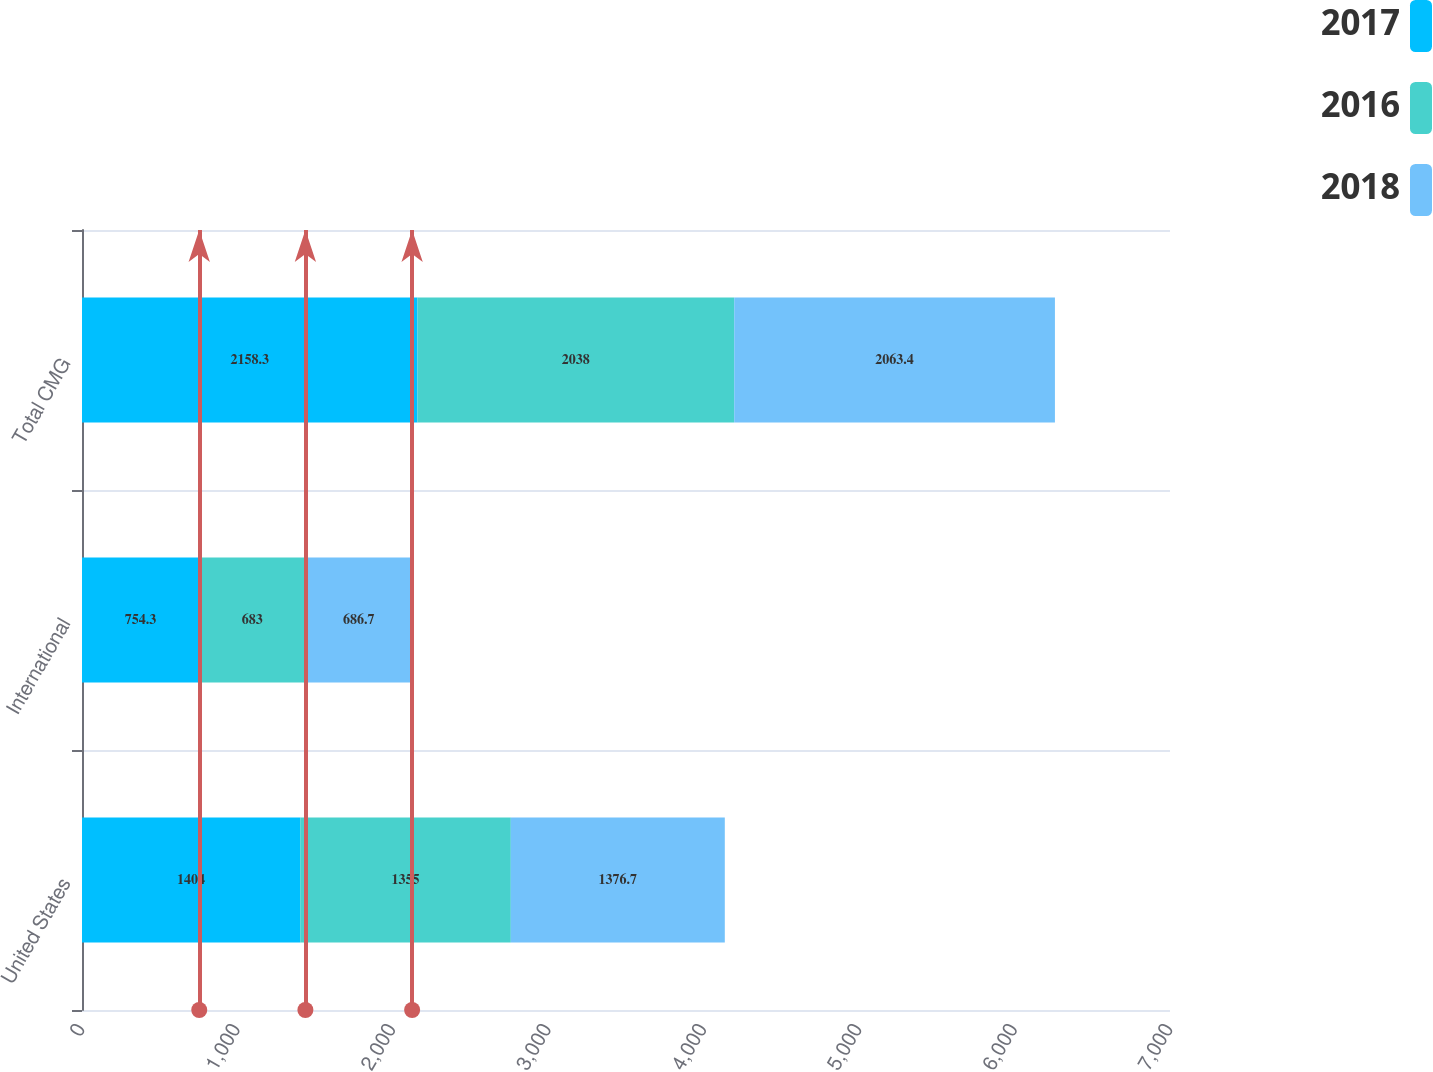Convert chart to OTSL. <chart><loc_0><loc_0><loc_500><loc_500><stacked_bar_chart><ecel><fcel>United States<fcel>International<fcel>Total CMG<nl><fcel>2017<fcel>1404<fcel>754.3<fcel>2158.3<nl><fcel>2016<fcel>1355<fcel>683<fcel>2038<nl><fcel>2018<fcel>1376.7<fcel>686.7<fcel>2063.4<nl></chart> 